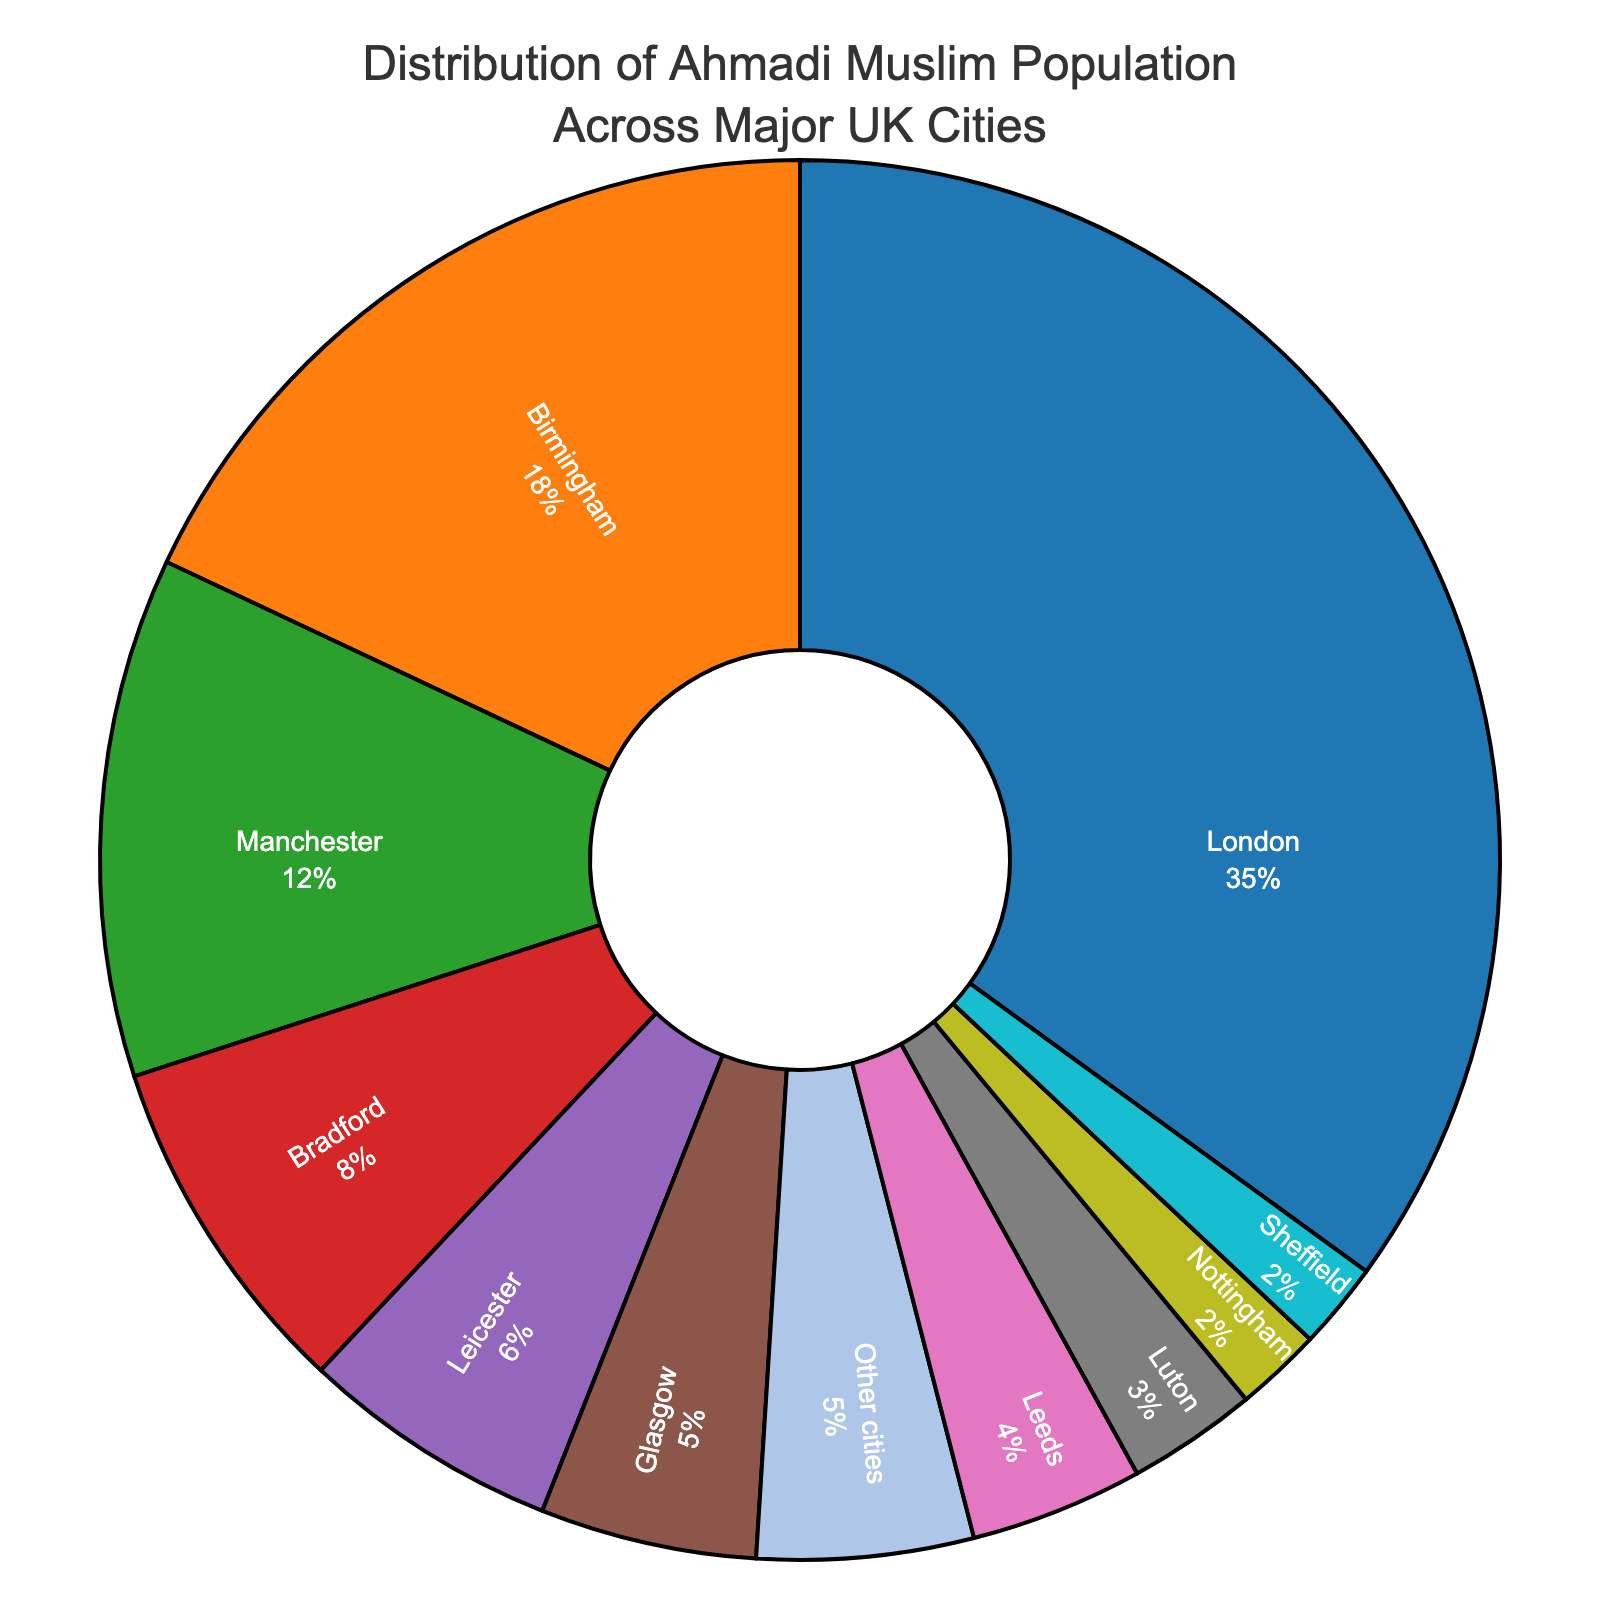What is the percentage of Ahmadi Muslims living in London compared to the total percentage of other cities combined? To find this, we note that London has 35%. We then sum up the percentages of all other cities: 18 + 12 + 8 + 6 + 5 + 4 + 3 + 2 + 2 + 5 = 65%. Thus, London is 35% compared to 65% for other cities.
Answer: London has 35% compared to 65% for other cities Which city has the second highest percentage of Ahmadi Muslims and what is that percentage? Birmingham has the second highest percentage at 18%. We confirm this by looking at the figure, where Birmingham is the second largest segment.
Answer: Birmingham, 18% How does the percentage of Ahmadi Muslims in Manchester compare to that in Glasgow? Manchester has 12%, while Glasgow has 5%. Manchester’s percentage is more than double that of Glasgow.
Answer: Manchester's percentage is more than double Glasgow's What's the total percentage of the Ahmadi Muslim population living in Manchester, Bradford, and Leicester combined? Adding the percentages for Manchester (12%), Bradford (8%), and Leicester (6%) gives: 12 + 8 + 6 = 26%.
Answer: 26% Which city has the smallest percentage of Ahmadi Muslims, and what is that percentage? Both Nottingham and Sheffield have the smallest percentage, each at 2%.
Answer: Nottingham and Sheffield, 2% How does the percentage of Ahmadi Muslims in Leeds compare to that in Luton? Leeds has 4%, while Luton has 3%, making Leeds' percentage slightly higher.
Answer: Leeds has 1% more than Luton If the total Ahmadi Muslim population in the UK is 100,000, how many Ahmadi Muslims live in Birmingham based on the given data? 18% of 100,000 gives the number of Ahmadi Muslims in Birmingham: 0.18 * 100,000 = 18,000.
Answer: 18,000 What is the combined percentage of the Ahmadi Muslim population in the five smallest cities listed? The five smallest percentages are: Leicester (6%), Glasgow (5%), Leeds (4%), Luton (3%), Nottingham (2%), and Sheffield (2%). Summing these gives: 6 + 5 + 4 + 3 + 2 + 2 = 22%.
Answer: 22% What percentage of Ahmadi Muslims live in cities with more than 10% of the population each? The cities above 10% are London (35%), Birmingham (18%), and Manchester (12%). Summing these gives: 35 + 18 + 12 = 65%.
Answer: 65% What is the average percentage of Ahmadi Muslims in the cities given excluding 'Other cities'? Summing the percentages excluding 'Other cities': 35 + 18 + 12 + 8 + 6 + 5 + 4 + 3 + 2 + 2 = 95%. There are 10 cities listed. So the average is 95 / 10 = 9.5%.
Answer: 9.5% 